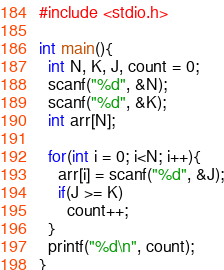Convert code to text. <code><loc_0><loc_0><loc_500><loc_500><_C_>#include <stdio.h>

int main(){
  int N, K, J, count = 0;
  scanf("%d", &N);
  scanf("%d", &K);
  int arr[N];
  
  for(int i = 0; i<N; i++){
    arr[i] = scanf("%d", &J);
  	if(J >= K)
      count++;
  }
  printf("%d\n", count);
}</code> 